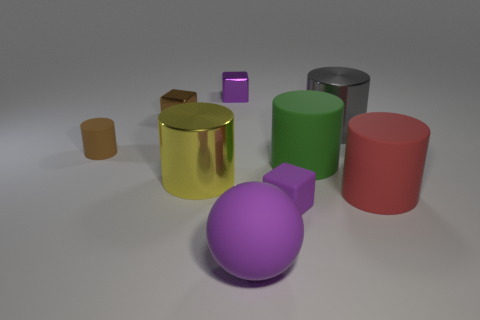How many purple cubes must be subtracted to get 1 purple cubes? 1 Subtract all yellow balls. How many purple blocks are left? 2 Subtract all tiny cylinders. How many cylinders are left? 4 Subtract all gray cylinders. How many cylinders are left? 4 Subtract 1 cylinders. How many cylinders are left? 4 Add 1 large blue balls. How many objects exist? 10 Subtract all yellow cylinders. Subtract all green spheres. How many cylinders are left? 4 Subtract all balls. How many objects are left? 8 Subtract all red rubber cylinders. Subtract all purple metallic cubes. How many objects are left? 7 Add 4 big yellow things. How many big yellow things are left? 5 